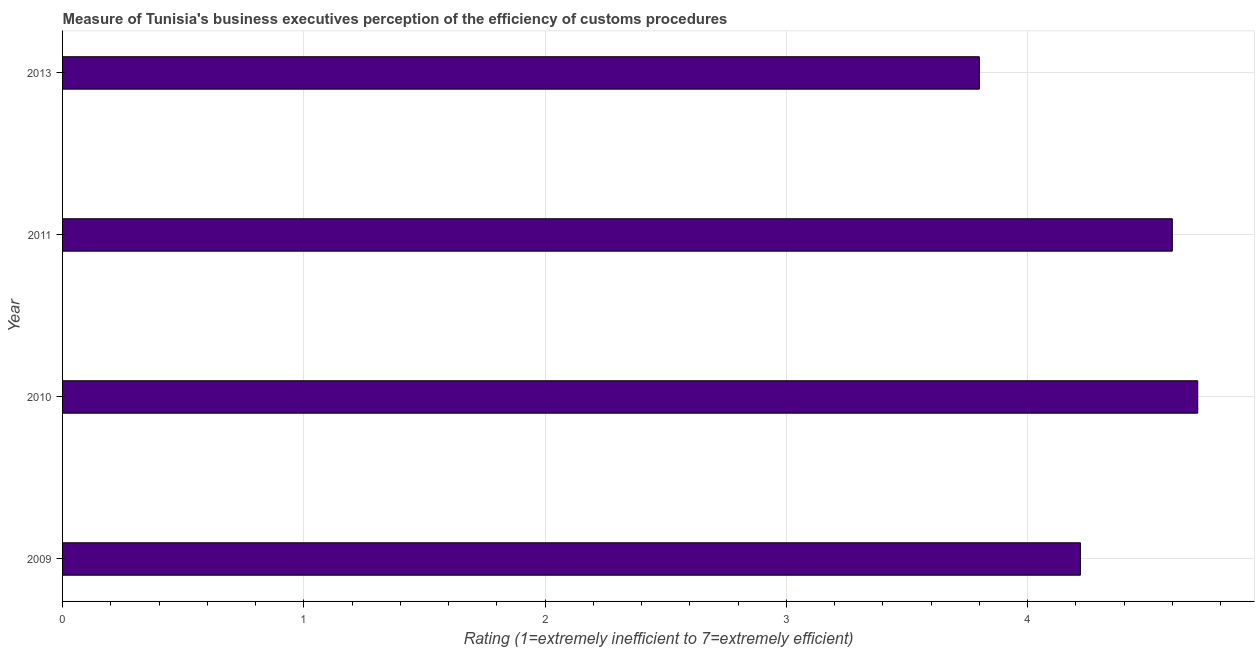What is the title of the graph?
Your answer should be compact. Measure of Tunisia's business executives perception of the efficiency of customs procedures. What is the label or title of the X-axis?
Give a very brief answer. Rating (1=extremely inefficient to 7=extremely efficient). What is the rating measuring burden of customs procedure in 2010?
Ensure brevity in your answer.  4.71. Across all years, what is the maximum rating measuring burden of customs procedure?
Offer a terse response. 4.71. Across all years, what is the minimum rating measuring burden of customs procedure?
Offer a terse response. 3.8. In which year was the rating measuring burden of customs procedure maximum?
Keep it short and to the point. 2010. What is the sum of the rating measuring burden of customs procedure?
Make the answer very short. 17.32. What is the difference between the rating measuring burden of customs procedure in 2010 and 2011?
Give a very brief answer. 0.1. What is the average rating measuring burden of customs procedure per year?
Give a very brief answer. 4.33. What is the median rating measuring burden of customs procedure?
Offer a terse response. 4.41. In how many years, is the rating measuring burden of customs procedure greater than 3.6 ?
Offer a terse response. 4. Do a majority of the years between 2009 and 2013 (inclusive) have rating measuring burden of customs procedure greater than 2.4 ?
Your response must be concise. Yes. What is the ratio of the rating measuring burden of customs procedure in 2010 to that in 2011?
Make the answer very short. 1.02. Is the difference between the rating measuring burden of customs procedure in 2010 and 2013 greater than the difference between any two years?
Offer a terse response. Yes. What is the difference between the highest and the second highest rating measuring burden of customs procedure?
Offer a terse response. 0.1. Is the sum of the rating measuring burden of customs procedure in 2009 and 2010 greater than the maximum rating measuring burden of customs procedure across all years?
Give a very brief answer. Yes. What is the difference between the highest and the lowest rating measuring burden of customs procedure?
Keep it short and to the point. 0.91. In how many years, is the rating measuring burden of customs procedure greater than the average rating measuring burden of customs procedure taken over all years?
Keep it short and to the point. 2. Are all the bars in the graph horizontal?
Give a very brief answer. Yes. Are the values on the major ticks of X-axis written in scientific E-notation?
Your response must be concise. No. What is the Rating (1=extremely inefficient to 7=extremely efficient) in 2009?
Give a very brief answer. 4.22. What is the Rating (1=extremely inefficient to 7=extremely efficient) of 2010?
Offer a terse response. 4.71. What is the Rating (1=extremely inefficient to 7=extremely efficient) in 2011?
Provide a succinct answer. 4.6. What is the Rating (1=extremely inefficient to 7=extremely efficient) in 2013?
Make the answer very short. 3.8. What is the difference between the Rating (1=extremely inefficient to 7=extremely efficient) in 2009 and 2010?
Make the answer very short. -0.49. What is the difference between the Rating (1=extremely inefficient to 7=extremely efficient) in 2009 and 2011?
Offer a very short reply. -0.38. What is the difference between the Rating (1=extremely inefficient to 7=extremely efficient) in 2009 and 2013?
Ensure brevity in your answer.  0.42. What is the difference between the Rating (1=extremely inefficient to 7=extremely efficient) in 2010 and 2011?
Give a very brief answer. 0.11. What is the difference between the Rating (1=extremely inefficient to 7=extremely efficient) in 2010 and 2013?
Keep it short and to the point. 0.91. What is the ratio of the Rating (1=extremely inefficient to 7=extremely efficient) in 2009 to that in 2010?
Your answer should be very brief. 0.9. What is the ratio of the Rating (1=extremely inefficient to 7=extremely efficient) in 2009 to that in 2011?
Give a very brief answer. 0.92. What is the ratio of the Rating (1=extremely inefficient to 7=extremely efficient) in 2009 to that in 2013?
Offer a very short reply. 1.11. What is the ratio of the Rating (1=extremely inefficient to 7=extremely efficient) in 2010 to that in 2013?
Offer a terse response. 1.24. What is the ratio of the Rating (1=extremely inefficient to 7=extremely efficient) in 2011 to that in 2013?
Provide a succinct answer. 1.21. 